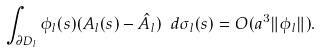Convert formula to latex. <formula><loc_0><loc_0><loc_500><loc_500>\int _ { \partial D _ { l } } \phi _ { l } ( s ) ( A _ { l } ( s ) - \hat { A } _ { l } ) \ d \sigma _ { l } ( s ) = O ( a ^ { 3 } \| \phi _ { l } \| ) .</formula> 